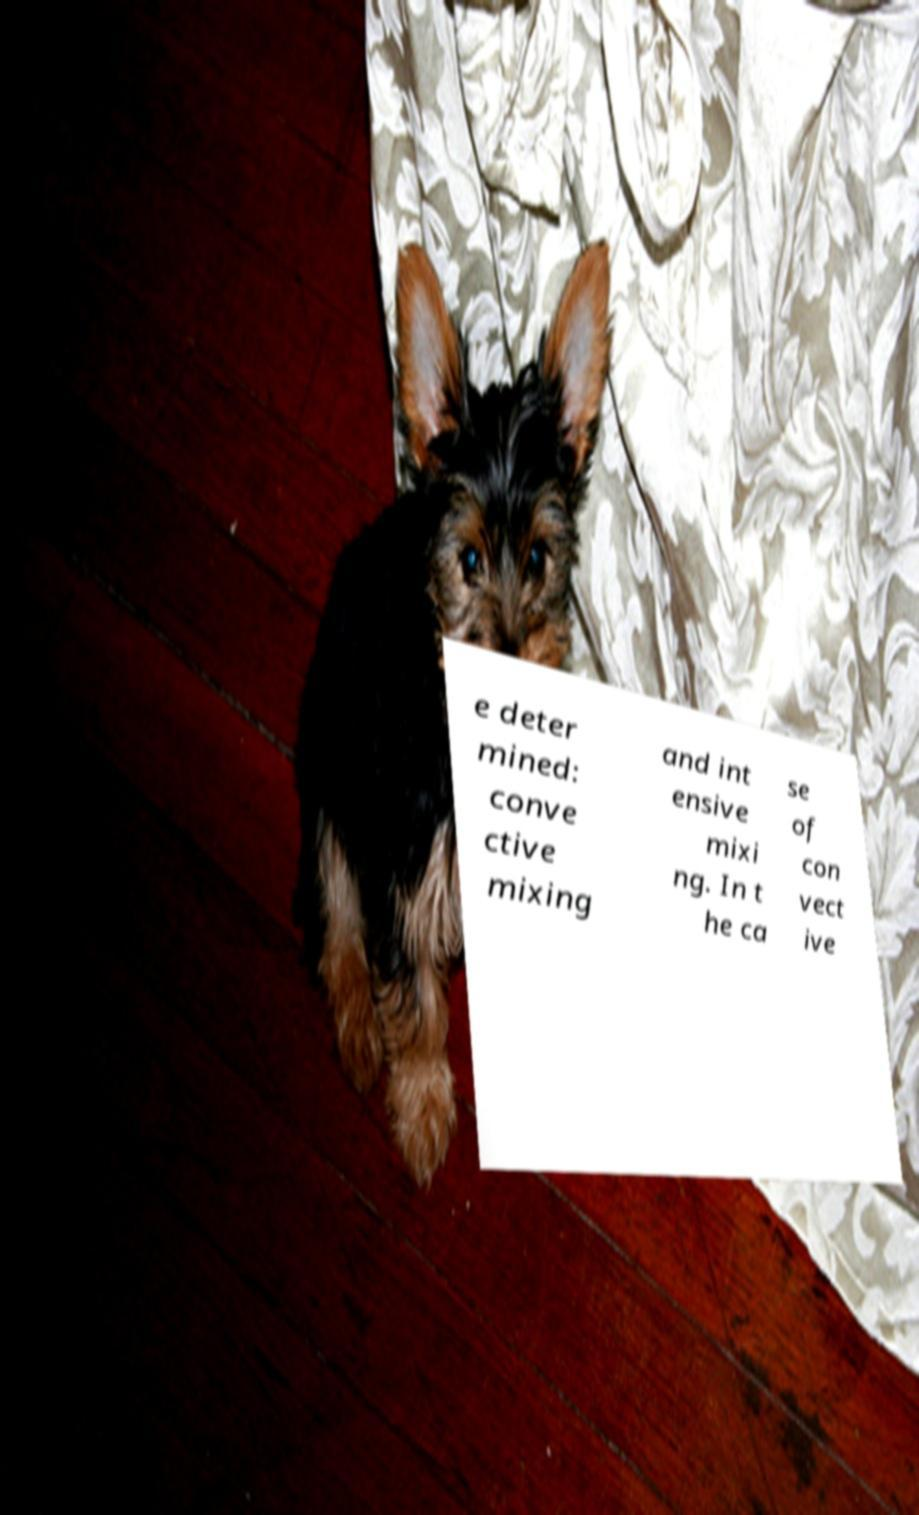I need the written content from this picture converted into text. Can you do that? e deter mined: conve ctive mixing and int ensive mixi ng. In t he ca se of con vect ive 